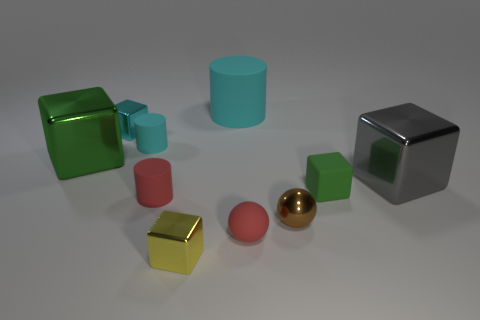There is a big green metal block; are there any tiny cubes in front of it?
Ensure brevity in your answer.  Yes. Do the red ball and the rubber cylinder in front of the large gray block have the same size?
Provide a short and direct response. Yes. The gray metallic object that is the same shape as the green matte object is what size?
Give a very brief answer. Large. Are there any other things that have the same material as the small yellow object?
Keep it short and to the point. Yes. Does the green cube that is on the left side of the tiny green cube have the same size as the rubber thing to the right of the metal ball?
Offer a terse response. No. How many large objects are gray matte balls or brown shiny objects?
Provide a succinct answer. 0. What number of things are on the left side of the gray metallic block and on the right side of the large cyan rubber cylinder?
Provide a succinct answer. 3. Is the material of the big cyan thing the same as the small block that is to the right of the brown thing?
Keep it short and to the point. Yes. What number of cyan objects are small shiny balls or big rubber blocks?
Offer a terse response. 0. Is there a blue metal cylinder that has the same size as the red ball?
Your answer should be compact. No. 